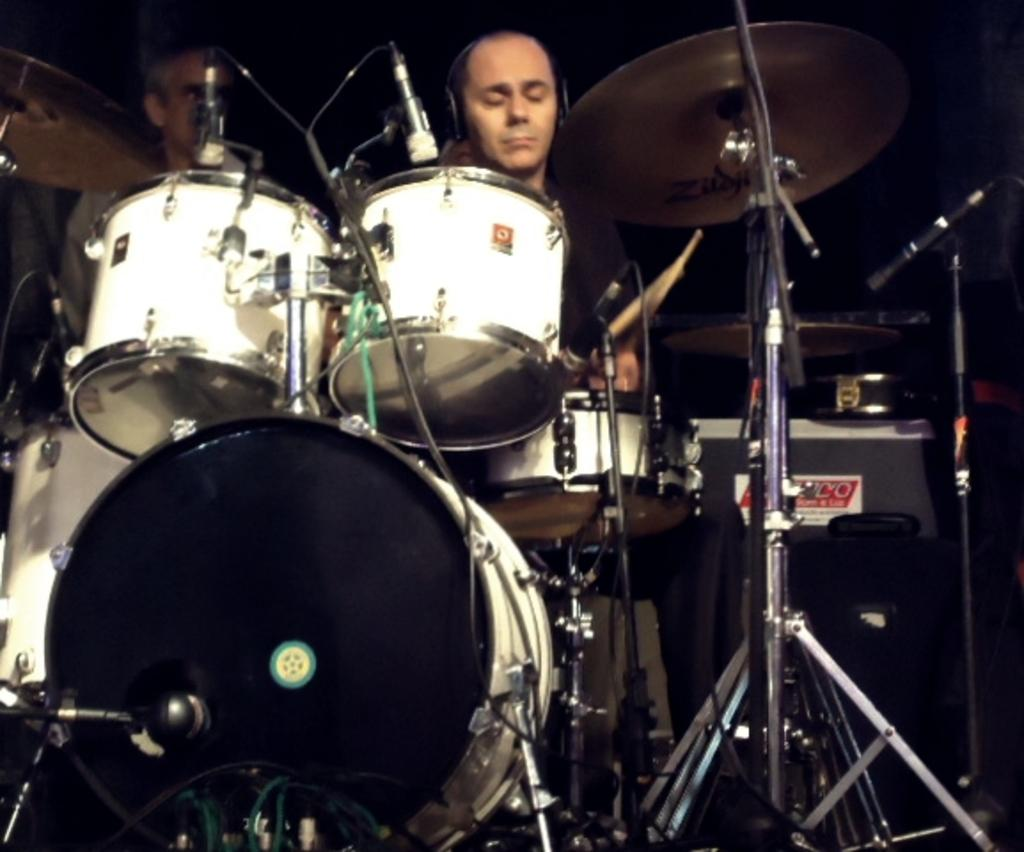How many people are in the image? There are two men in the image. What is one of the men doing in the image? One of the men is playing drums. Can you describe the background of the image? The background of the image is dark. What type of seed is being used to play the drums in the image? There is no seed present in the image, and the drums are being played with drumsticks, not seeds. 